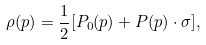<formula> <loc_0><loc_0><loc_500><loc_500>\rho ( p ) = \frac { 1 } { 2 } [ P _ { 0 } ( p ) + { P } ( p ) \cdot \sigma ] ,</formula> 